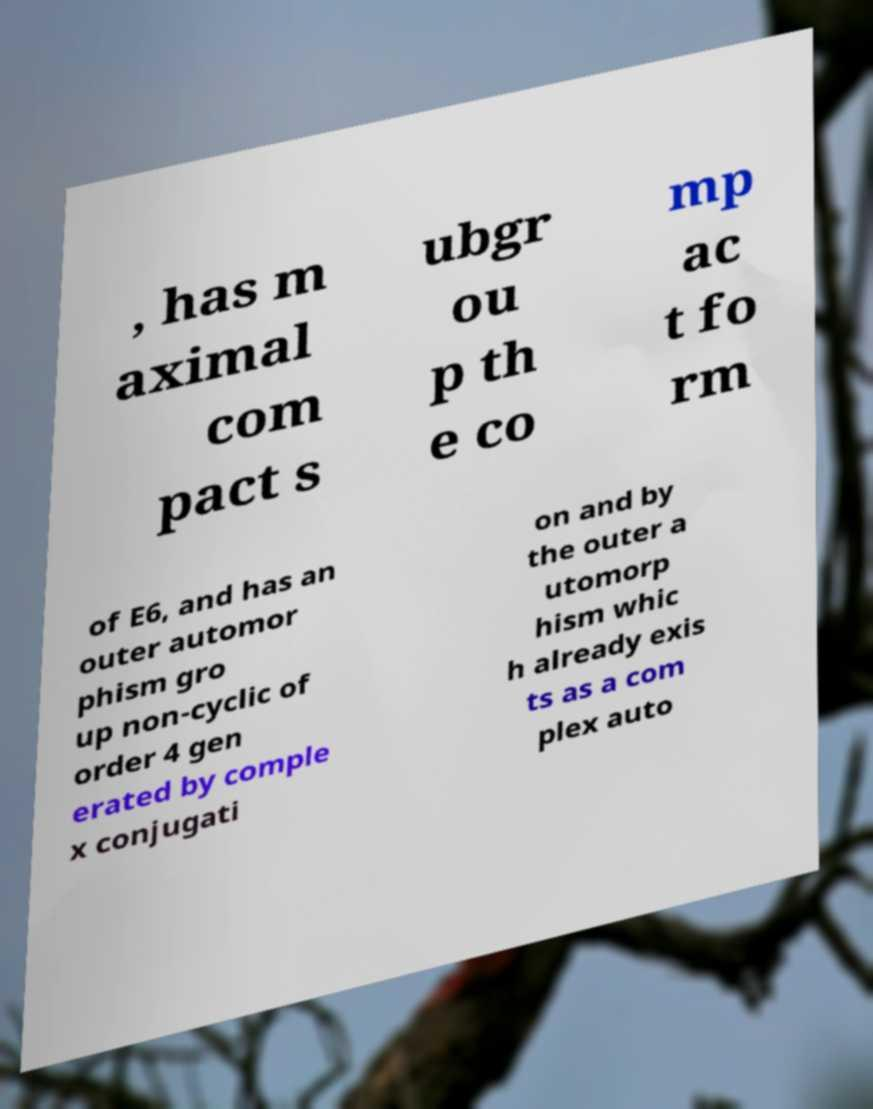I need the written content from this picture converted into text. Can you do that? , has m aximal com pact s ubgr ou p th e co mp ac t fo rm of E6, and has an outer automor phism gro up non-cyclic of order 4 gen erated by comple x conjugati on and by the outer a utomorp hism whic h already exis ts as a com plex auto 